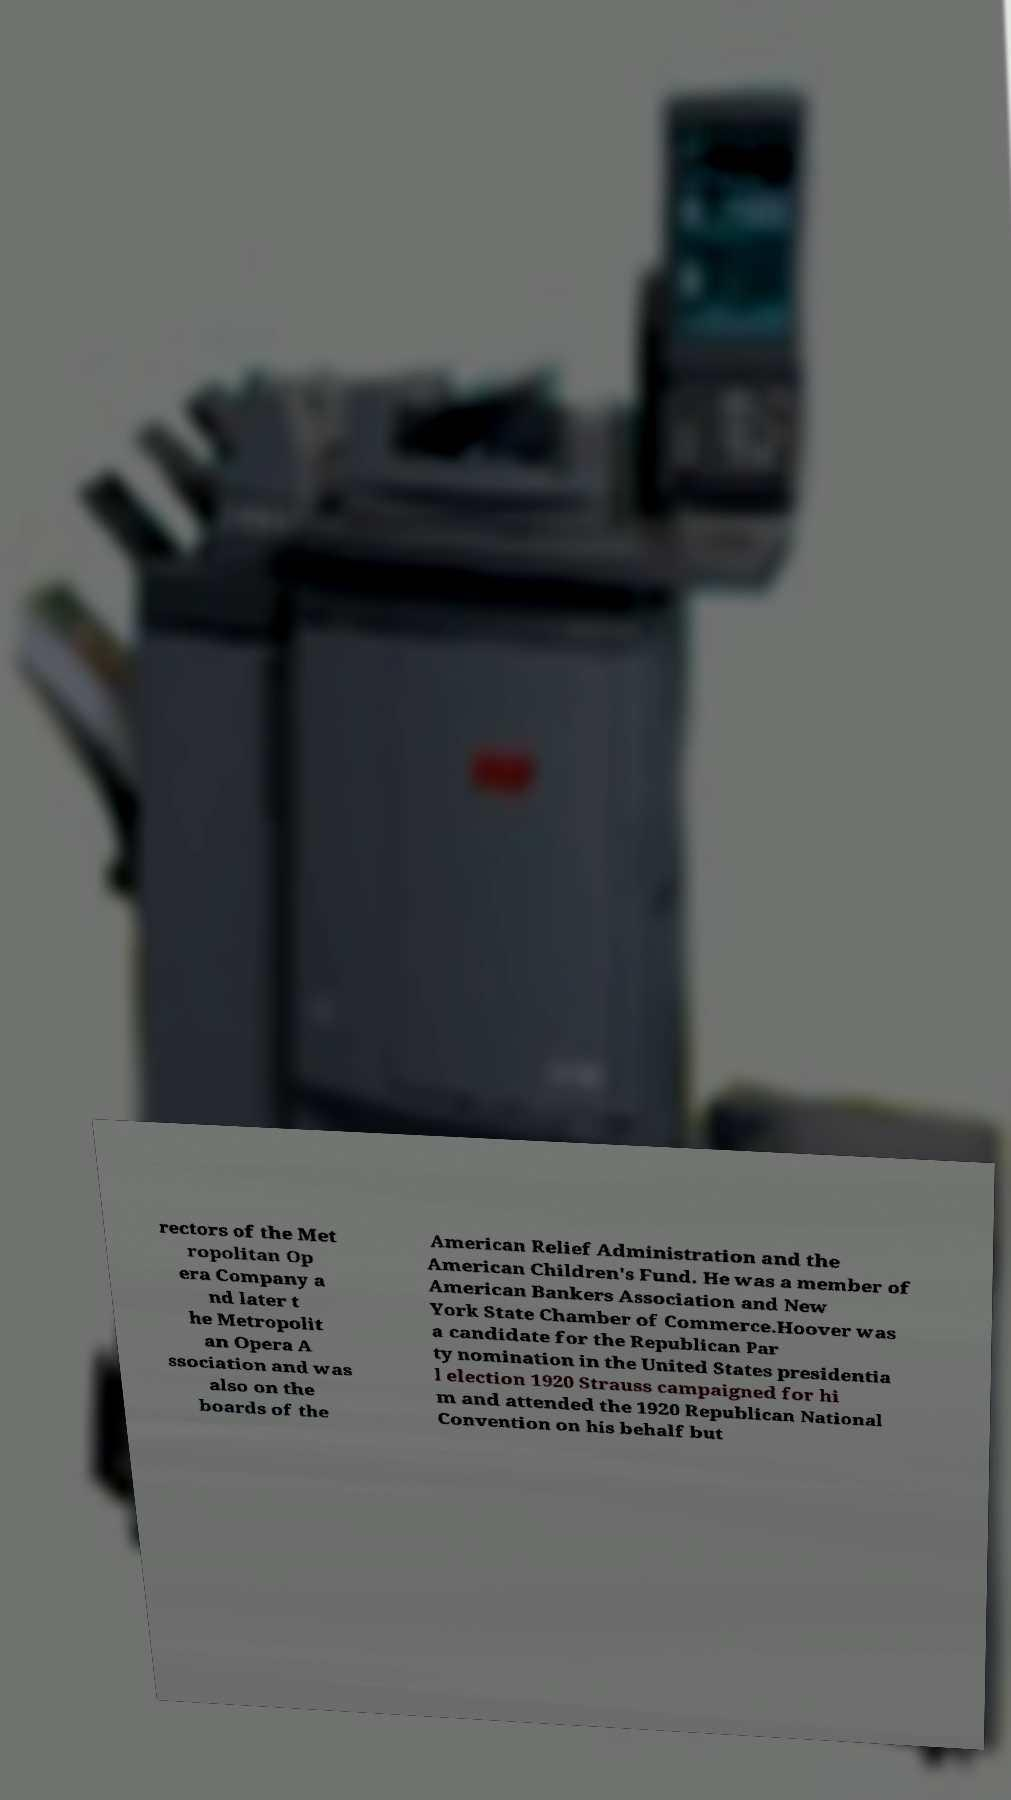Please identify and transcribe the text found in this image. rectors of the Met ropolitan Op era Company a nd later t he Metropolit an Opera A ssociation and was also on the boards of the American Relief Administration and the American Children's Fund. He was a member of American Bankers Association and New York State Chamber of Commerce.Hoover was a candidate for the Republican Par ty nomination in the United States presidentia l election 1920 Strauss campaigned for hi m and attended the 1920 Republican National Convention on his behalf but 